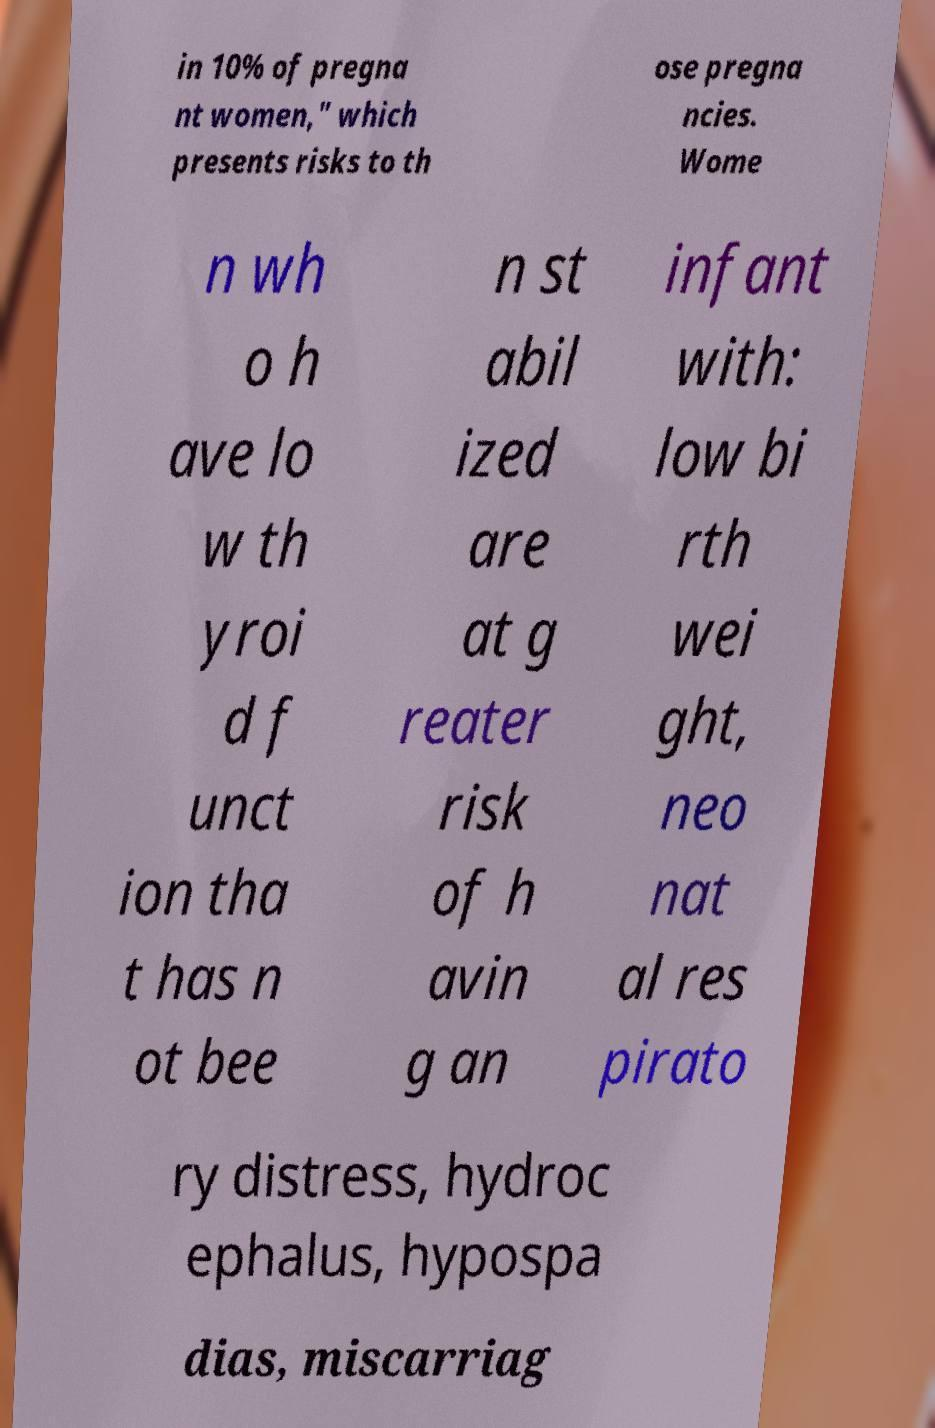Can you read and provide the text displayed in the image?This photo seems to have some interesting text. Can you extract and type it out for me? in 10% of pregna nt women," which presents risks to th ose pregna ncies. Wome n wh o h ave lo w th yroi d f unct ion tha t has n ot bee n st abil ized are at g reater risk of h avin g an infant with: low bi rth wei ght, neo nat al res pirato ry distress, hydroc ephalus, hypospa dias, miscarriag 